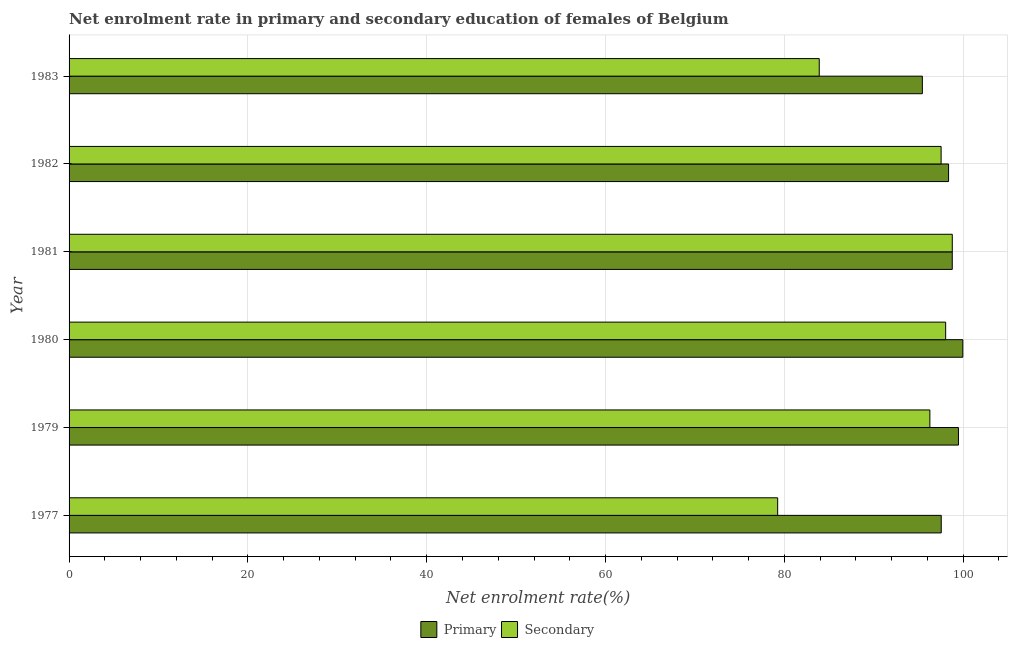How many different coloured bars are there?
Ensure brevity in your answer.  2. How many groups of bars are there?
Give a very brief answer. 6. Are the number of bars on each tick of the Y-axis equal?
Provide a succinct answer. Yes. What is the label of the 6th group of bars from the top?
Ensure brevity in your answer.  1977. In how many cases, is the number of bars for a given year not equal to the number of legend labels?
Your answer should be compact. 0. What is the enrollment rate in primary education in 1982?
Provide a short and direct response. 98.37. Across all years, what is the maximum enrollment rate in primary education?
Keep it short and to the point. 99.96. Across all years, what is the minimum enrollment rate in secondary education?
Your answer should be compact. 79.25. In which year was the enrollment rate in secondary education maximum?
Keep it short and to the point. 1981. In which year was the enrollment rate in secondary education minimum?
Your response must be concise. 1977. What is the total enrollment rate in secondary education in the graph?
Keep it short and to the point. 553.78. What is the difference between the enrollment rate in secondary education in 1977 and that in 1983?
Your answer should be compact. -4.65. What is the difference between the enrollment rate in secondary education in 1982 and the enrollment rate in primary education in 1983?
Make the answer very short. 2.1. What is the average enrollment rate in primary education per year?
Make the answer very short. 98.26. In the year 1982, what is the difference between the enrollment rate in primary education and enrollment rate in secondary education?
Give a very brief answer. 0.83. In how many years, is the enrollment rate in secondary education greater than 8 %?
Your response must be concise. 6. What is the ratio of the enrollment rate in secondary education in 1981 to that in 1982?
Your response must be concise. 1.01. Is the difference between the enrollment rate in primary education in 1979 and 1982 greater than the difference between the enrollment rate in secondary education in 1979 and 1982?
Offer a very short reply. Yes. What is the difference between the highest and the second highest enrollment rate in secondary education?
Your answer should be very brief. 0.74. What is the difference between the highest and the lowest enrollment rate in secondary education?
Your answer should be very brief. 19.53. Is the sum of the enrollment rate in primary education in 1977 and 1979 greater than the maximum enrollment rate in secondary education across all years?
Offer a terse response. Yes. What does the 1st bar from the top in 1980 represents?
Offer a very short reply. Secondary. What does the 1st bar from the bottom in 1977 represents?
Your response must be concise. Primary. How many bars are there?
Offer a terse response. 12. Are all the bars in the graph horizontal?
Ensure brevity in your answer.  Yes. Does the graph contain any zero values?
Keep it short and to the point. No. Does the graph contain grids?
Offer a very short reply. Yes. How many legend labels are there?
Your response must be concise. 2. What is the title of the graph?
Your answer should be very brief. Net enrolment rate in primary and secondary education of females of Belgium. Does "Ages 15-24" appear as one of the legend labels in the graph?
Your answer should be compact. No. What is the label or title of the X-axis?
Your answer should be compact. Net enrolment rate(%). What is the label or title of the Y-axis?
Ensure brevity in your answer.  Year. What is the Net enrolment rate(%) of Primary in 1977?
Your answer should be very brief. 97.54. What is the Net enrolment rate(%) of Secondary in 1977?
Offer a terse response. 79.25. What is the Net enrolment rate(%) in Primary in 1979?
Offer a terse response. 99.47. What is the Net enrolment rate(%) in Secondary in 1979?
Offer a terse response. 96.27. What is the Net enrolment rate(%) in Primary in 1980?
Your answer should be very brief. 99.96. What is the Net enrolment rate(%) of Secondary in 1980?
Give a very brief answer. 98.04. What is the Net enrolment rate(%) in Primary in 1981?
Your answer should be compact. 98.78. What is the Net enrolment rate(%) in Secondary in 1981?
Give a very brief answer. 98.78. What is the Net enrolment rate(%) of Primary in 1982?
Give a very brief answer. 98.37. What is the Net enrolment rate(%) in Secondary in 1982?
Provide a short and direct response. 97.53. What is the Net enrolment rate(%) of Primary in 1983?
Your response must be concise. 95.43. What is the Net enrolment rate(%) in Secondary in 1983?
Give a very brief answer. 83.9. Across all years, what is the maximum Net enrolment rate(%) of Primary?
Your answer should be compact. 99.96. Across all years, what is the maximum Net enrolment rate(%) in Secondary?
Ensure brevity in your answer.  98.78. Across all years, what is the minimum Net enrolment rate(%) in Primary?
Ensure brevity in your answer.  95.43. Across all years, what is the minimum Net enrolment rate(%) of Secondary?
Give a very brief answer. 79.25. What is the total Net enrolment rate(%) of Primary in the graph?
Give a very brief answer. 589.55. What is the total Net enrolment rate(%) in Secondary in the graph?
Give a very brief answer. 553.78. What is the difference between the Net enrolment rate(%) in Primary in 1977 and that in 1979?
Your answer should be compact. -1.92. What is the difference between the Net enrolment rate(%) of Secondary in 1977 and that in 1979?
Your answer should be very brief. -17.02. What is the difference between the Net enrolment rate(%) in Primary in 1977 and that in 1980?
Provide a short and direct response. -2.41. What is the difference between the Net enrolment rate(%) of Secondary in 1977 and that in 1980?
Provide a succinct answer. -18.79. What is the difference between the Net enrolment rate(%) in Primary in 1977 and that in 1981?
Keep it short and to the point. -1.23. What is the difference between the Net enrolment rate(%) of Secondary in 1977 and that in 1981?
Your answer should be very brief. -19.53. What is the difference between the Net enrolment rate(%) of Primary in 1977 and that in 1982?
Your answer should be compact. -0.82. What is the difference between the Net enrolment rate(%) of Secondary in 1977 and that in 1982?
Provide a succinct answer. -18.28. What is the difference between the Net enrolment rate(%) of Primary in 1977 and that in 1983?
Make the answer very short. 2.11. What is the difference between the Net enrolment rate(%) in Secondary in 1977 and that in 1983?
Offer a terse response. -4.65. What is the difference between the Net enrolment rate(%) of Primary in 1979 and that in 1980?
Provide a short and direct response. -0.49. What is the difference between the Net enrolment rate(%) of Secondary in 1979 and that in 1980?
Offer a terse response. -1.77. What is the difference between the Net enrolment rate(%) in Primary in 1979 and that in 1981?
Your answer should be very brief. 0.69. What is the difference between the Net enrolment rate(%) in Secondary in 1979 and that in 1981?
Your response must be concise. -2.51. What is the difference between the Net enrolment rate(%) in Primary in 1979 and that in 1982?
Give a very brief answer. 1.1. What is the difference between the Net enrolment rate(%) of Secondary in 1979 and that in 1982?
Offer a very short reply. -1.26. What is the difference between the Net enrolment rate(%) in Primary in 1979 and that in 1983?
Make the answer very short. 4.04. What is the difference between the Net enrolment rate(%) in Secondary in 1979 and that in 1983?
Your answer should be very brief. 12.37. What is the difference between the Net enrolment rate(%) of Primary in 1980 and that in 1981?
Offer a terse response. 1.18. What is the difference between the Net enrolment rate(%) in Secondary in 1980 and that in 1981?
Ensure brevity in your answer.  -0.74. What is the difference between the Net enrolment rate(%) of Primary in 1980 and that in 1982?
Ensure brevity in your answer.  1.59. What is the difference between the Net enrolment rate(%) in Secondary in 1980 and that in 1982?
Give a very brief answer. 0.51. What is the difference between the Net enrolment rate(%) of Primary in 1980 and that in 1983?
Your answer should be very brief. 4.52. What is the difference between the Net enrolment rate(%) in Secondary in 1980 and that in 1983?
Your answer should be compact. 14.14. What is the difference between the Net enrolment rate(%) in Primary in 1981 and that in 1982?
Provide a succinct answer. 0.41. What is the difference between the Net enrolment rate(%) of Secondary in 1981 and that in 1982?
Provide a succinct answer. 1.25. What is the difference between the Net enrolment rate(%) of Primary in 1981 and that in 1983?
Offer a terse response. 3.34. What is the difference between the Net enrolment rate(%) in Secondary in 1981 and that in 1983?
Your answer should be compact. 14.88. What is the difference between the Net enrolment rate(%) of Primary in 1982 and that in 1983?
Your response must be concise. 2.93. What is the difference between the Net enrolment rate(%) in Secondary in 1982 and that in 1983?
Provide a short and direct response. 13.63. What is the difference between the Net enrolment rate(%) of Primary in 1977 and the Net enrolment rate(%) of Secondary in 1979?
Provide a succinct answer. 1.27. What is the difference between the Net enrolment rate(%) of Primary in 1977 and the Net enrolment rate(%) of Secondary in 1980?
Offer a terse response. -0.49. What is the difference between the Net enrolment rate(%) of Primary in 1977 and the Net enrolment rate(%) of Secondary in 1981?
Offer a terse response. -1.23. What is the difference between the Net enrolment rate(%) of Primary in 1977 and the Net enrolment rate(%) of Secondary in 1982?
Your response must be concise. 0.01. What is the difference between the Net enrolment rate(%) of Primary in 1977 and the Net enrolment rate(%) of Secondary in 1983?
Provide a succinct answer. 13.64. What is the difference between the Net enrolment rate(%) of Primary in 1979 and the Net enrolment rate(%) of Secondary in 1980?
Provide a short and direct response. 1.43. What is the difference between the Net enrolment rate(%) of Primary in 1979 and the Net enrolment rate(%) of Secondary in 1981?
Ensure brevity in your answer.  0.69. What is the difference between the Net enrolment rate(%) in Primary in 1979 and the Net enrolment rate(%) in Secondary in 1982?
Your answer should be very brief. 1.94. What is the difference between the Net enrolment rate(%) in Primary in 1979 and the Net enrolment rate(%) in Secondary in 1983?
Keep it short and to the point. 15.57. What is the difference between the Net enrolment rate(%) of Primary in 1980 and the Net enrolment rate(%) of Secondary in 1981?
Your response must be concise. 1.18. What is the difference between the Net enrolment rate(%) of Primary in 1980 and the Net enrolment rate(%) of Secondary in 1982?
Offer a very short reply. 2.43. What is the difference between the Net enrolment rate(%) of Primary in 1980 and the Net enrolment rate(%) of Secondary in 1983?
Your answer should be very brief. 16.06. What is the difference between the Net enrolment rate(%) in Primary in 1981 and the Net enrolment rate(%) in Secondary in 1982?
Ensure brevity in your answer.  1.25. What is the difference between the Net enrolment rate(%) in Primary in 1981 and the Net enrolment rate(%) in Secondary in 1983?
Provide a succinct answer. 14.88. What is the difference between the Net enrolment rate(%) of Primary in 1982 and the Net enrolment rate(%) of Secondary in 1983?
Offer a very short reply. 14.46. What is the average Net enrolment rate(%) of Primary per year?
Your answer should be very brief. 98.26. What is the average Net enrolment rate(%) in Secondary per year?
Make the answer very short. 92.3. In the year 1977, what is the difference between the Net enrolment rate(%) in Primary and Net enrolment rate(%) in Secondary?
Ensure brevity in your answer.  18.29. In the year 1979, what is the difference between the Net enrolment rate(%) in Primary and Net enrolment rate(%) in Secondary?
Offer a very short reply. 3.2. In the year 1980, what is the difference between the Net enrolment rate(%) in Primary and Net enrolment rate(%) in Secondary?
Provide a succinct answer. 1.92. In the year 1981, what is the difference between the Net enrolment rate(%) in Primary and Net enrolment rate(%) in Secondary?
Keep it short and to the point. -0. In the year 1982, what is the difference between the Net enrolment rate(%) of Primary and Net enrolment rate(%) of Secondary?
Provide a short and direct response. 0.83. In the year 1983, what is the difference between the Net enrolment rate(%) of Primary and Net enrolment rate(%) of Secondary?
Your answer should be compact. 11.53. What is the ratio of the Net enrolment rate(%) of Primary in 1977 to that in 1979?
Your answer should be compact. 0.98. What is the ratio of the Net enrolment rate(%) in Secondary in 1977 to that in 1979?
Your answer should be compact. 0.82. What is the ratio of the Net enrolment rate(%) of Primary in 1977 to that in 1980?
Your answer should be compact. 0.98. What is the ratio of the Net enrolment rate(%) in Secondary in 1977 to that in 1980?
Your response must be concise. 0.81. What is the ratio of the Net enrolment rate(%) of Primary in 1977 to that in 1981?
Your answer should be very brief. 0.99. What is the ratio of the Net enrolment rate(%) of Secondary in 1977 to that in 1981?
Give a very brief answer. 0.8. What is the ratio of the Net enrolment rate(%) of Secondary in 1977 to that in 1982?
Provide a short and direct response. 0.81. What is the ratio of the Net enrolment rate(%) of Primary in 1977 to that in 1983?
Your response must be concise. 1.02. What is the ratio of the Net enrolment rate(%) in Secondary in 1977 to that in 1983?
Keep it short and to the point. 0.94. What is the ratio of the Net enrolment rate(%) of Primary in 1979 to that in 1980?
Make the answer very short. 1. What is the ratio of the Net enrolment rate(%) of Secondary in 1979 to that in 1981?
Ensure brevity in your answer.  0.97. What is the ratio of the Net enrolment rate(%) of Primary in 1979 to that in 1982?
Provide a succinct answer. 1.01. What is the ratio of the Net enrolment rate(%) of Secondary in 1979 to that in 1982?
Your answer should be very brief. 0.99. What is the ratio of the Net enrolment rate(%) of Primary in 1979 to that in 1983?
Keep it short and to the point. 1.04. What is the ratio of the Net enrolment rate(%) of Secondary in 1979 to that in 1983?
Keep it short and to the point. 1.15. What is the ratio of the Net enrolment rate(%) in Primary in 1980 to that in 1981?
Make the answer very short. 1.01. What is the ratio of the Net enrolment rate(%) of Secondary in 1980 to that in 1981?
Keep it short and to the point. 0.99. What is the ratio of the Net enrolment rate(%) in Primary in 1980 to that in 1982?
Your answer should be very brief. 1.02. What is the ratio of the Net enrolment rate(%) in Secondary in 1980 to that in 1982?
Your answer should be very brief. 1.01. What is the ratio of the Net enrolment rate(%) of Primary in 1980 to that in 1983?
Offer a very short reply. 1.05. What is the ratio of the Net enrolment rate(%) in Secondary in 1980 to that in 1983?
Your answer should be very brief. 1.17. What is the ratio of the Net enrolment rate(%) of Primary in 1981 to that in 1982?
Keep it short and to the point. 1. What is the ratio of the Net enrolment rate(%) of Secondary in 1981 to that in 1982?
Your response must be concise. 1.01. What is the ratio of the Net enrolment rate(%) of Primary in 1981 to that in 1983?
Your answer should be compact. 1.03. What is the ratio of the Net enrolment rate(%) of Secondary in 1981 to that in 1983?
Keep it short and to the point. 1.18. What is the ratio of the Net enrolment rate(%) of Primary in 1982 to that in 1983?
Offer a terse response. 1.03. What is the ratio of the Net enrolment rate(%) of Secondary in 1982 to that in 1983?
Provide a short and direct response. 1.16. What is the difference between the highest and the second highest Net enrolment rate(%) in Primary?
Give a very brief answer. 0.49. What is the difference between the highest and the second highest Net enrolment rate(%) of Secondary?
Provide a short and direct response. 0.74. What is the difference between the highest and the lowest Net enrolment rate(%) in Primary?
Make the answer very short. 4.52. What is the difference between the highest and the lowest Net enrolment rate(%) of Secondary?
Keep it short and to the point. 19.53. 